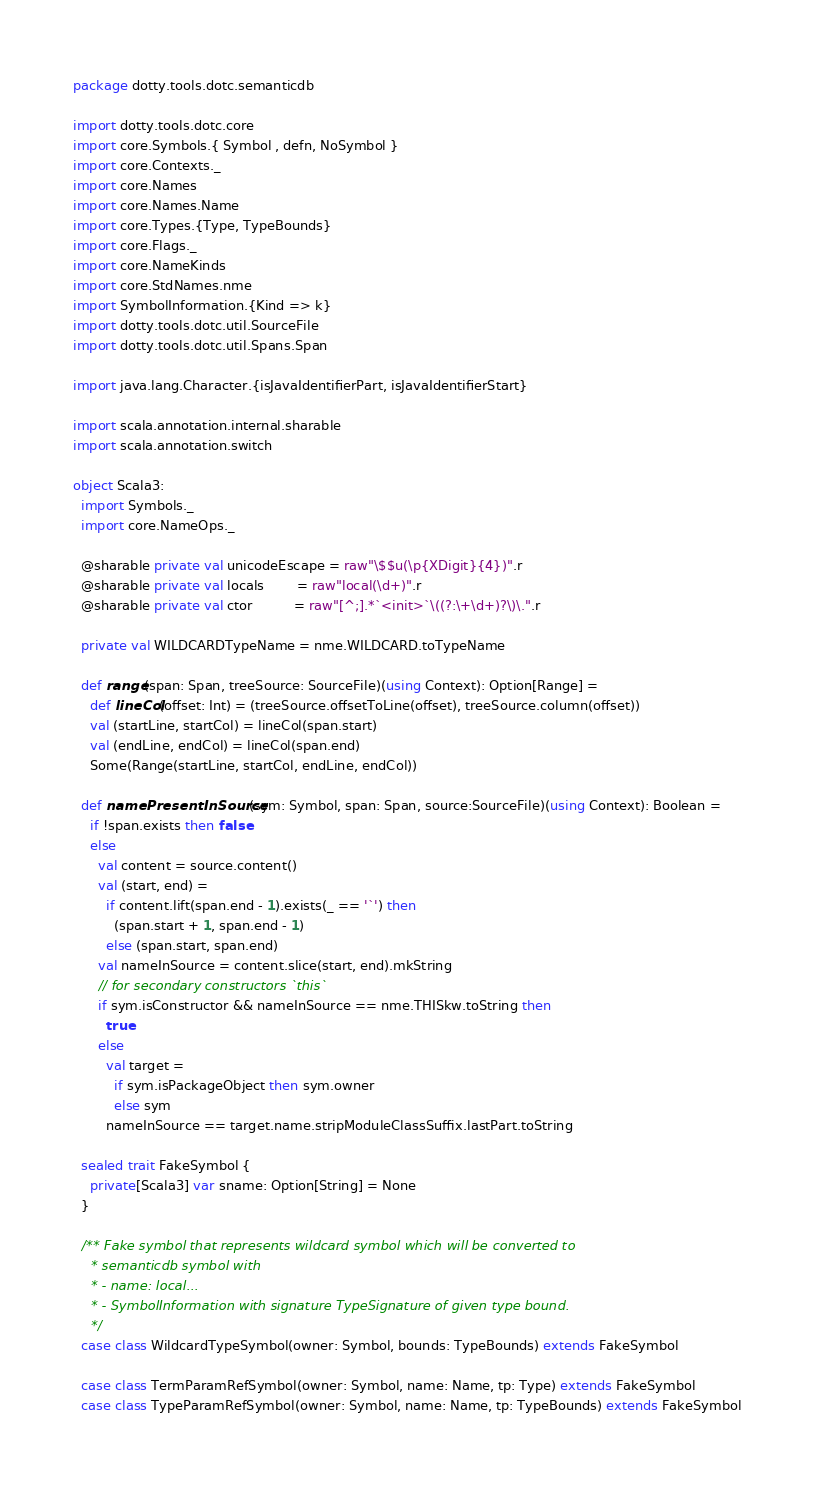<code> <loc_0><loc_0><loc_500><loc_500><_Scala_>package dotty.tools.dotc.semanticdb

import dotty.tools.dotc.core
import core.Symbols.{ Symbol , defn, NoSymbol }
import core.Contexts._
import core.Names
import core.Names.Name
import core.Types.{Type, TypeBounds}
import core.Flags._
import core.NameKinds
import core.StdNames.nme
import SymbolInformation.{Kind => k}
import dotty.tools.dotc.util.SourceFile
import dotty.tools.dotc.util.Spans.Span

import java.lang.Character.{isJavaIdentifierPart, isJavaIdentifierStart}

import scala.annotation.internal.sharable
import scala.annotation.switch

object Scala3:
  import Symbols._
  import core.NameOps._

  @sharable private val unicodeEscape = raw"\$$u(\p{XDigit}{4})".r
  @sharable private val locals        = raw"local(\d+)".r
  @sharable private val ctor          = raw"[^;].*`<init>`\((?:\+\d+)?\)\.".r

  private val WILDCARDTypeName = nme.WILDCARD.toTypeName

  def range(span: Span, treeSource: SourceFile)(using Context): Option[Range] =
    def lineCol(offset: Int) = (treeSource.offsetToLine(offset), treeSource.column(offset))
    val (startLine, startCol) = lineCol(span.start)
    val (endLine, endCol) = lineCol(span.end)
    Some(Range(startLine, startCol, endLine, endCol))

  def namePresentInSource(sym: Symbol, span: Span, source:SourceFile)(using Context): Boolean =
    if !span.exists then false
    else
      val content = source.content()
      val (start, end) =
        if content.lift(span.end - 1).exists(_ == '`') then
          (span.start + 1, span.end - 1)
        else (span.start, span.end)
      val nameInSource = content.slice(start, end).mkString
      // for secondary constructors `this`
      if sym.isConstructor && nameInSource == nme.THISkw.toString then
        true
      else
        val target =
          if sym.isPackageObject then sym.owner
          else sym
        nameInSource == target.name.stripModuleClassSuffix.lastPart.toString

  sealed trait FakeSymbol {
    private[Scala3] var sname: Option[String] = None
  }

  /** Fake symbol that represents wildcard symbol which will be converted to
    * semanticdb symbol with
    * - name: local...
    * - SymbolInformation with signature TypeSignature of given type bound.
    */
  case class WildcardTypeSymbol(owner: Symbol, bounds: TypeBounds) extends FakeSymbol

  case class TermParamRefSymbol(owner: Symbol, name: Name, tp: Type) extends FakeSymbol
  case class TypeParamRefSymbol(owner: Symbol, name: Name, tp: TypeBounds) extends FakeSymbol</code> 